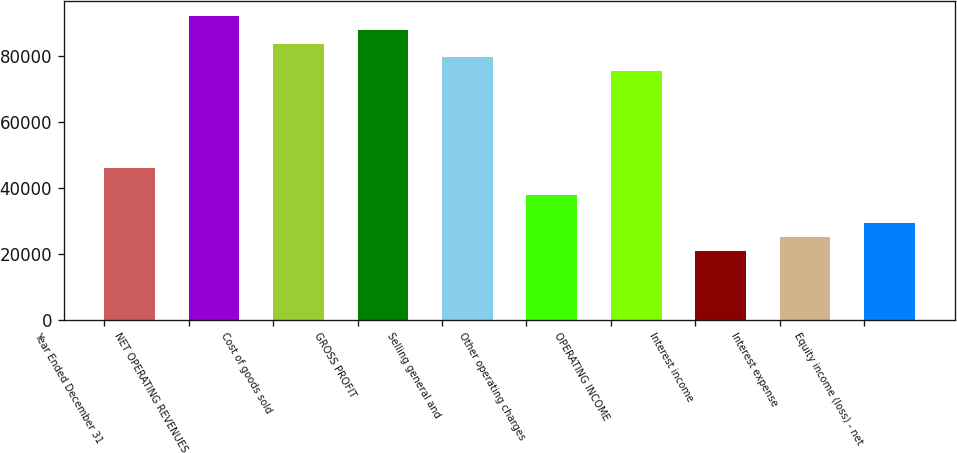Convert chart to OTSL. <chart><loc_0><loc_0><loc_500><loc_500><bar_chart><fcel>Year Ended December 31<fcel>NET OPERATING REVENUES<fcel>Cost of goods sold<fcel>GROSS PROFIT<fcel>Selling general and<fcel>Other operating charges<fcel>OPERATING INCOME<fcel>Interest income<fcel>Interest expense<fcel>Equity income (loss) - net<nl><fcel>46049.1<fcel>92096.8<fcel>83724.5<fcel>87910.6<fcel>79538.3<fcel>37676.8<fcel>75352.2<fcel>20932.2<fcel>25118.4<fcel>29304.5<nl></chart> 